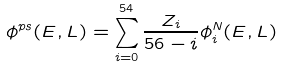<formula> <loc_0><loc_0><loc_500><loc_500>\phi ^ { p s } ( E , L ) = \sum _ { i = 0 } ^ { 5 4 } \frac { Z _ { i } } { 5 6 - i } \phi _ { i } ^ { N } ( E , L )</formula> 